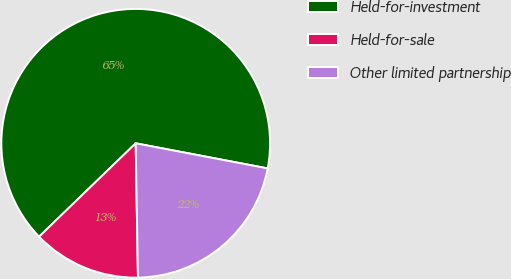<chart> <loc_0><loc_0><loc_500><loc_500><pie_chart><fcel>Held-for-investment<fcel>Held-for-sale<fcel>Other limited partnership<nl><fcel>65.22%<fcel>13.04%<fcel>21.74%<nl></chart> 